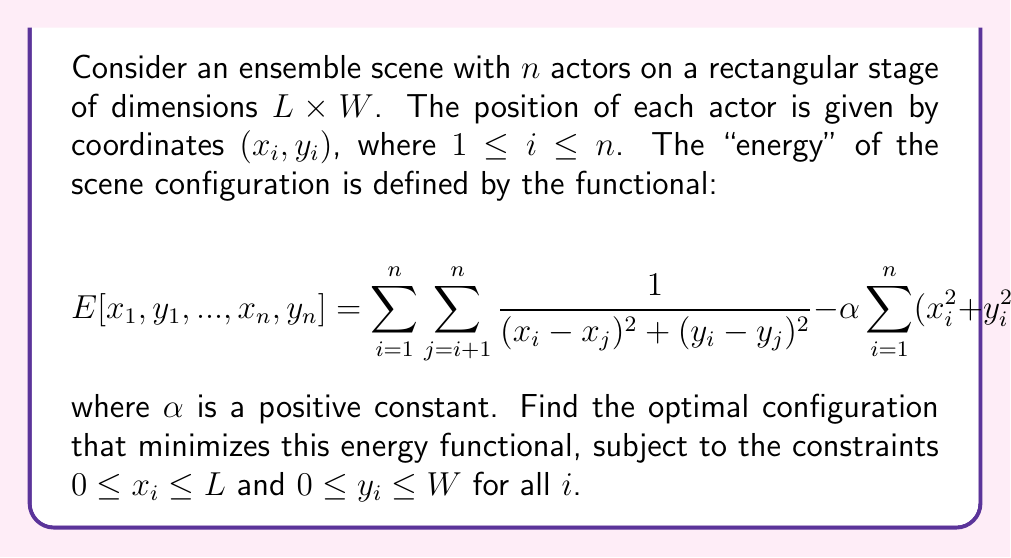Show me your answer to this math problem. To solve this variational problem, we need to use the calculus of variations and the method of Lagrange multipliers. Here's a step-by-step approach:

1) First, we form the Lagrangian functional by adding constraint terms:

   $$\mathcal{L} = E[x_1, y_1, ..., x_n, y_n] + \sum_{i=1}^n (\lambda_i x_i + \mu_i (L-x_i) + \nu_i y_i + \rho_i (W-y_i))$$

   where $\lambda_i, \mu_i, \nu_i, \rho_i$ are Lagrange multipliers.

2) We then take the partial derivatives of $\mathcal{L}$ with respect to each $x_i$ and $y_i$ and set them to zero:

   $$\frac{\partial \mathcal{L}}{\partial x_i} = -2\sum_{j \neq i} \frac{x_i - x_j}{((x_i - x_j)^2 + (y_i - y_j)^2)^2} - 2\alpha x_i + \lambda_i - \mu_i = 0$$

   $$\frac{\partial \mathcal{L}}{\partial y_i} = -2\sum_{j \neq i} \frac{y_i - y_j}{((x_i - x_j)^2 + (y_i - y_j)^2)^2} - 2\alpha y_i + \nu_i - \rho_i = 0$$

3) These equations, along with the complementary slackness conditions:

   $$\lambda_i x_i = 0, \mu_i (L-x_i) = 0, \nu_i y_i = 0, \rho_i (W-y_i) = 0$$

   form a system of equations that determine the optimal configuration.

4) Due to the symmetry of the problem, we can deduce that the optimal configuration will have actors spread out as much as possible, pushing towards the corners and edges of the stage.

5) For a small number of actors (n ≤ 4), they will occupy the corners. For larger n, some actors will be positioned along the edges.

6) The exact positions will depend on the values of L, W, and α, and would require numerical methods to solve precisely.

7) In the limit of large α, the actors will be pushed towards the center of the stage, while for small α, they will spread out more.
Answer: The optimal configuration minimizing the energy functional will have actors spread out towards the corners and edges of the stage, with exact positions depending on the values of L, W, α, and n. For n ≤ 4, actors will occupy the corners. For n > 4, some actors will be positioned along the edges. Precise positions require numerical solution of the derived system of equations. 